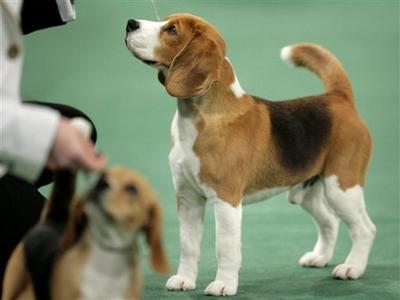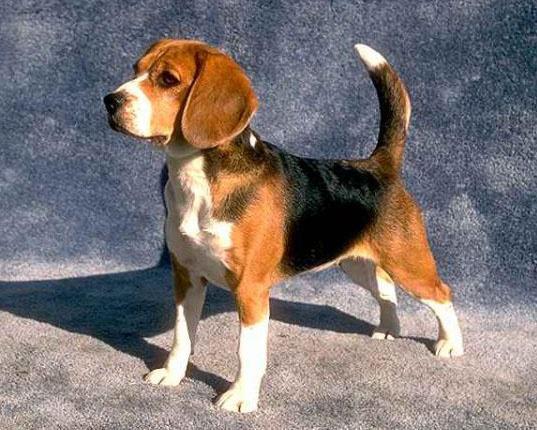The first image is the image on the left, the second image is the image on the right. Evaluate the accuracy of this statement regarding the images: "The dog in each image is on a leash.". Is it true? Answer yes or no. No. 